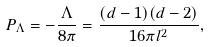Convert formula to latex. <formula><loc_0><loc_0><loc_500><loc_500>P _ { \Lambda } = - \frac { \Lambda } { 8 \pi } = \frac { ( d - 1 ) ( d - 2 ) } { 1 6 \pi l ^ { 2 } } ,</formula> 